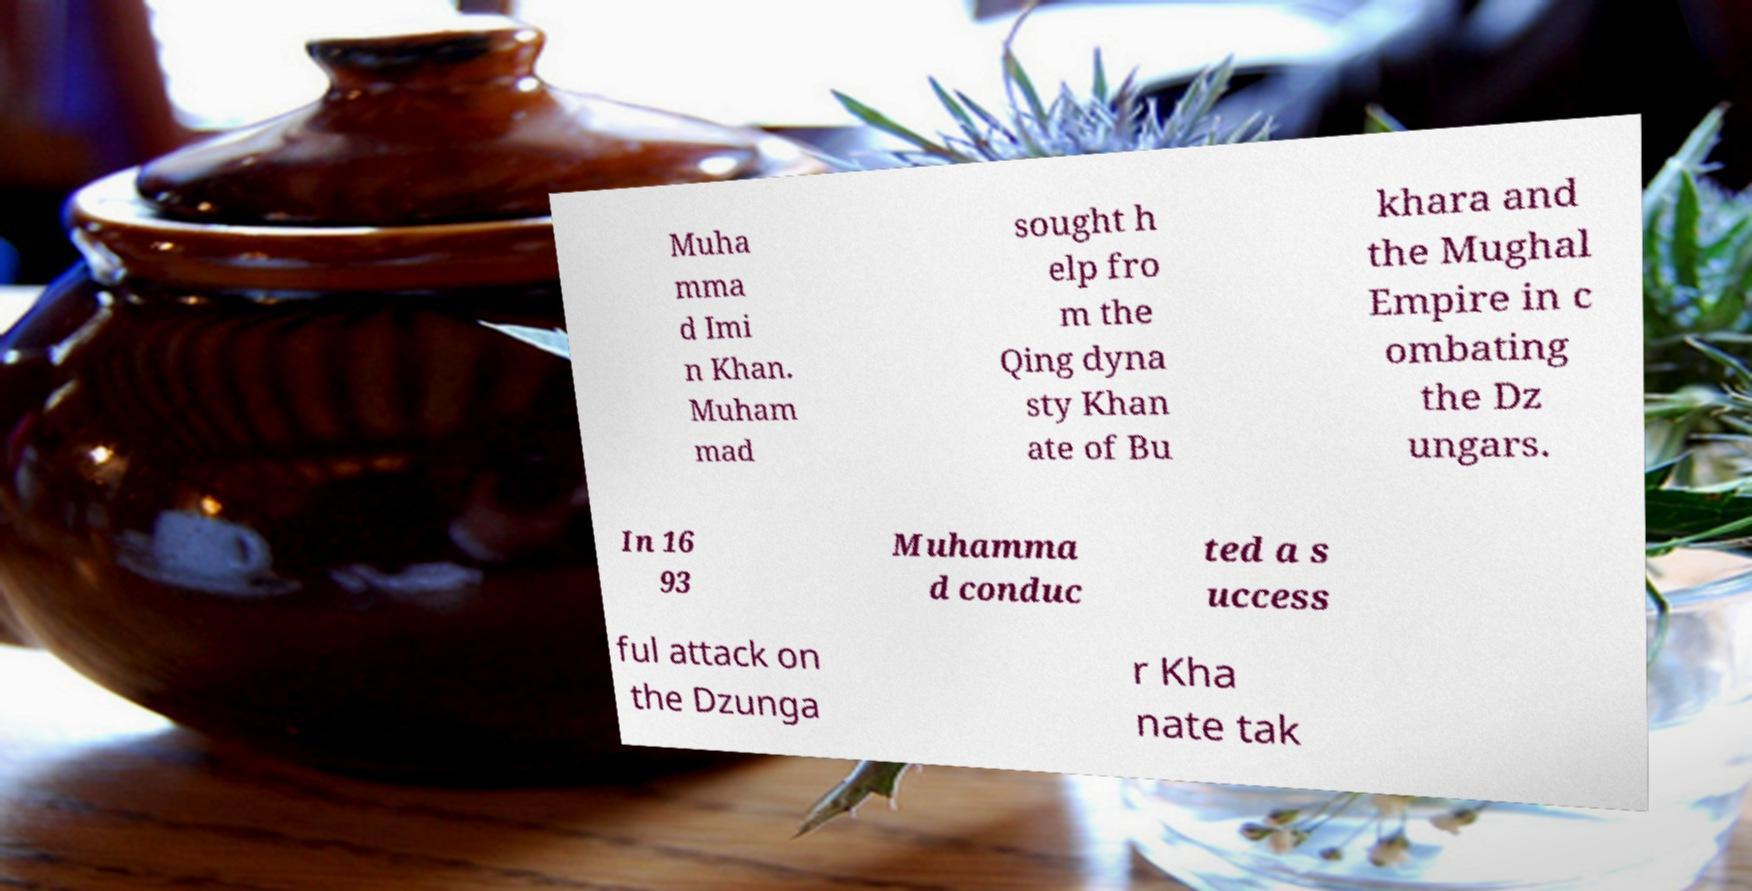Please identify and transcribe the text found in this image. Muha mma d Imi n Khan. Muham mad sought h elp fro m the Qing dyna sty Khan ate of Bu khara and the Mughal Empire in c ombating the Dz ungars. In 16 93 Muhamma d conduc ted a s uccess ful attack on the Dzunga r Kha nate tak 